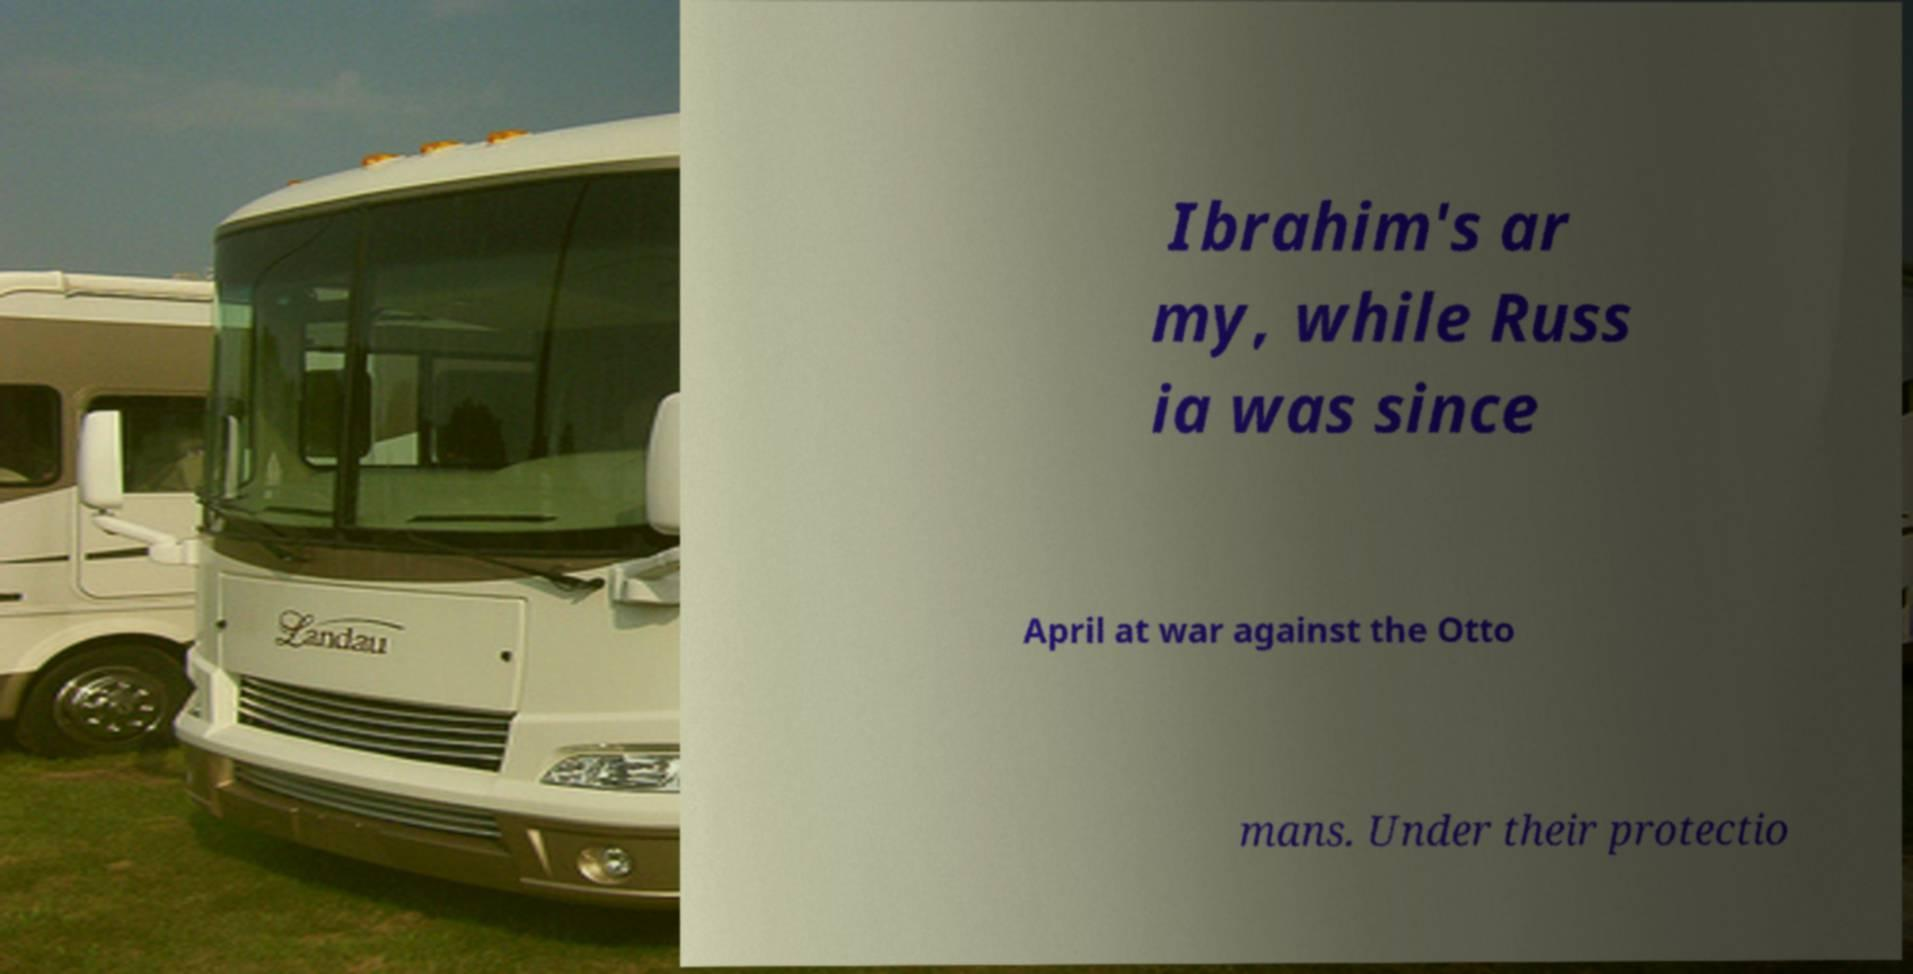There's text embedded in this image that I need extracted. Can you transcribe it verbatim? Ibrahim's ar my, while Russ ia was since April at war against the Otto mans. Under their protectio 